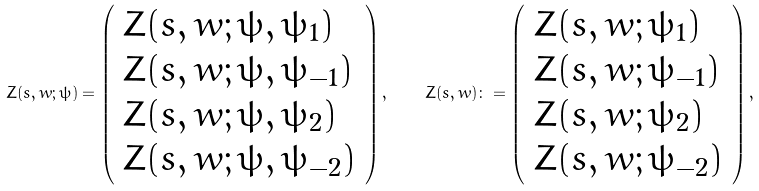Convert formula to latex. <formula><loc_0><loc_0><loc_500><loc_500>Z ( s , w ; \psi ) = \left ( \begin{array} { l } Z ( s , w ; \psi , \psi _ { 1 } ) \\ Z ( s , w ; \psi , \psi _ { - 1 } ) \\ Z ( s , w ; \psi , \psi _ { 2 } ) \\ Z ( s , w ; \psi , \psi _ { - 2 } ) \end{array} \right ) , \quad Z ( s , w ) \colon = \left ( \begin{array} { l } Z ( s , w ; \psi _ { 1 } ) \\ Z ( s , w ; \psi _ { - 1 } ) \\ Z ( s , w ; \psi _ { 2 } ) \\ Z ( s , w ; \psi _ { - 2 } ) \end{array} \right ) ,</formula> 